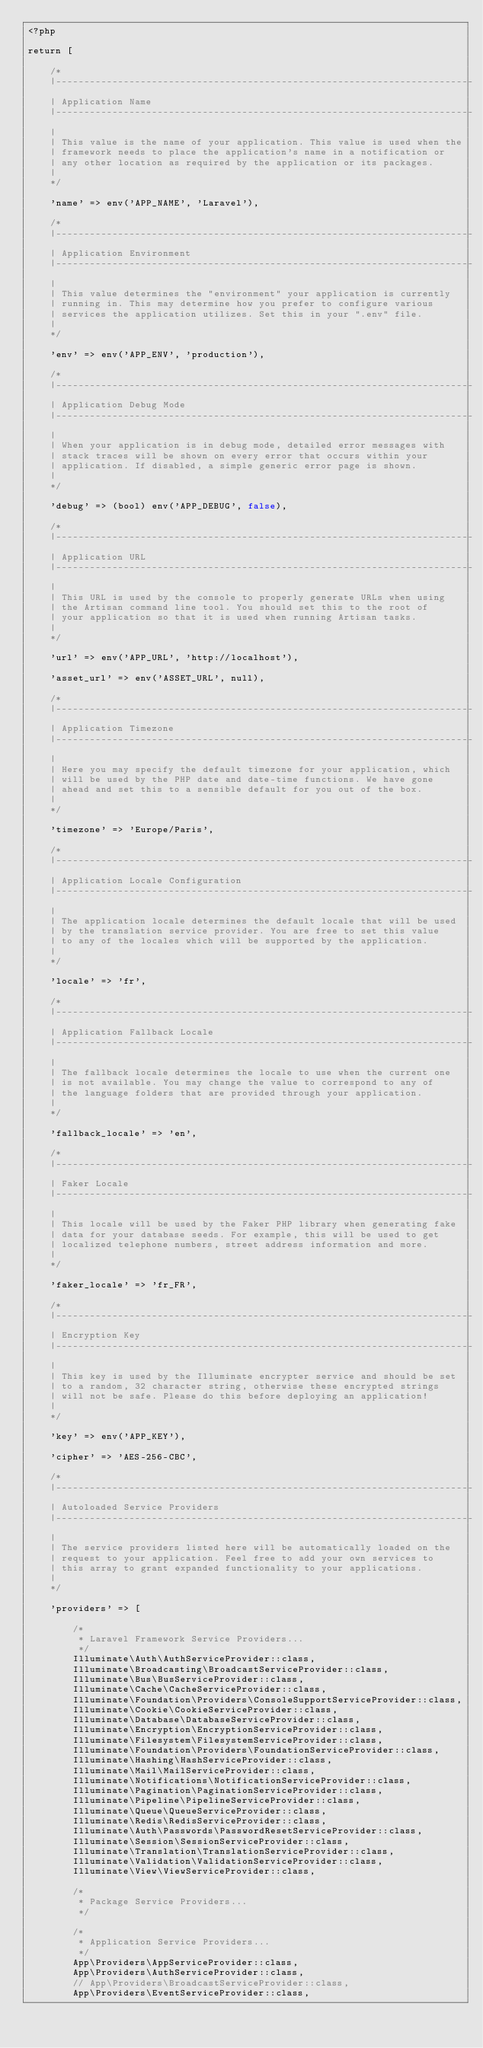Convert code to text. <code><loc_0><loc_0><loc_500><loc_500><_PHP_><?php

return [

    /*
    |--------------------------------------------------------------------------
    | Application Name
    |--------------------------------------------------------------------------
    |
    | This value is the name of your application. This value is used when the
    | framework needs to place the application's name in a notification or
    | any other location as required by the application or its packages.
    |
    */

    'name' => env('APP_NAME', 'Laravel'),

    /*
    |--------------------------------------------------------------------------
    | Application Environment
    |--------------------------------------------------------------------------
    |
    | This value determines the "environment" your application is currently
    | running in. This may determine how you prefer to configure various
    | services the application utilizes. Set this in your ".env" file.
    |
    */

    'env' => env('APP_ENV', 'production'),

    /*
    |--------------------------------------------------------------------------
    | Application Debug Mode
    |--------------------------------------------------------------------------
    |
    | When your application is in debug mode, detailed error messages with
    | stack traces will be shown on every error that occurs within your
    | application. If disabled, a simple generic error page is shown.
    |
    */

    'debug' => (bool) env('APP_DEBUG', false),

    /*
    |--------------------------------------------------------------------------
    | Application URL
    |--------------------------------------------------------------------------
    |
    | This URL is used by the console to properly generate URLs when using
    | the Artisan command line tool. You should set this to the root of
    | your application so that it is used when running Artisan tasks.
    |
    */

    'url' => env('APP_URL', 'http://localhost'),

    'asset_url' => env('ASSET_URL', null),

    /*
    |--------------------------------------------------------------------------
    | Application Timezone
    |--------------------------------------------------------------------------
    |
    | Here you may specify the default timezone for your application, which
    | will be used by the PHP date and date-time functions. We have gone
    | ahead and set this to a sensible default for you out of the box.
    |
    */

    'timezone' => 'Europe/Paris',

    /*
    |--------------------------------------------------------------------------
    | Application Locale Configuration
    |--------------------------------------------------------------------------
    |
    | The application locale determines the default locale that will be used
    | by the translation service provider. You are free to set this value
    | to any of the locales which will be supported by the application.
    |
    */

    'locale' => 'fr',

    /*
    |--------------------------------------------------------------------------
    | Application Fallback Locale
    |--------------------------------------------------------------------------
    |
    | The fallback locale determines the locale to use when the current one
    | is not available. You may change the value to correspond to any of
    | the language folders that are provided through your application.
    |
    */

    'fallback_locale' => 'en',

    /*
    |--------------------------------------------------------------------------
    | Faker Locale
    |--------------------------------------------------------------------------
    |
    | This locale will be used by the Faker PHP library when generating fake
    | data for your database seeds. For example, this will be used to get
    | localized telephone numbers, street address information and more.
    |
    */

    'faker_locale' => 'fr_FR',

    /*
    |--------------------------------------------------------------------------
    | Encryption Key
    |--------------------------------------------------------------------------
    |
    | This key is used by the Illuminate encrypter service and should be set
    | to a random, 32 character string, otherwise these encrypted strings
    | will not be safe. Please do this before deploying an application!
    |
    */

    'key' => env('APP_KEY'),

    'cipher' => 'AES-256-CBC',

    /*
    |--------------------------------------------------------------------------
    | Autoloaded Service Providers
    |--------------------------------------------------------------------------
    |
    | The service providers listed here will be automatically loaded on the
    | request to your application. Feel free to add your own services to
    | this array to grant expanded functionality to your applications.
    |
    */

    'providers' => [

        /*
         * Laravel Framework Service Providers...
         */
        Illuminate\Auth\AuthServiceProvider::class,
        Illuminate\Broadcasting\BroadcastServiceProvider::class,
        Illuminate\Bus\BusServiceProvider::class,
        Illuminate\Cache\CacheServiceProvider::class,
        Illuminate\Foundation\Providers\ConsoleSupportServiceProvider::class,
        Illuminate\Cookie\CookieServiceProvider::class,
        Illuminate\Database\DatabaseServiceProvider::class,
        Illuminate\Encryption\EncryptionServiceProvider::class,
        Illuminate\Filesystem\FilesystemServiceProvider::class,
        Illuminate\Foundation\Providers\FoundationServiceProvider::class,
        Illuminate\Hashing\HashServiceProvider::class,
        Illuminate\Mail\MailServiceProvider::class,
        Illuminate\Notifications\NotificationServiceProvider::class,
        Illuminate\Pagination\PaginationServiceProvider::class,
        Illuminate\Pipeline\PipelineServiceProvider::class,
        Illuminate\Queue\QueueServiceProvider::class,
        Illuminate\Redis\RedisServiceProvider::class,
        Illuminate\Auth\Passwords\PasswordResetServiceProvider::class,
        Illuminate\Session\SessionServiceProvider::class,
        Illuminate\Translation\TranslationServiceProvider::class,
        Illuminate\Validation\ValidationServiceProvider::class,
        Illuminate\View\ViewServiceProvider::class,

        /*
         * Package Service Providers...
         */

        /*
         * Application Service Providers...
         */
        App\Providers\AppServiceProvider::class,
        App\Providers\AuthServiceProvider::class,
        // App\Providers\BroadcastServiceProvider::class,
        App\Providers\EventServiceProvider::class,</code> 